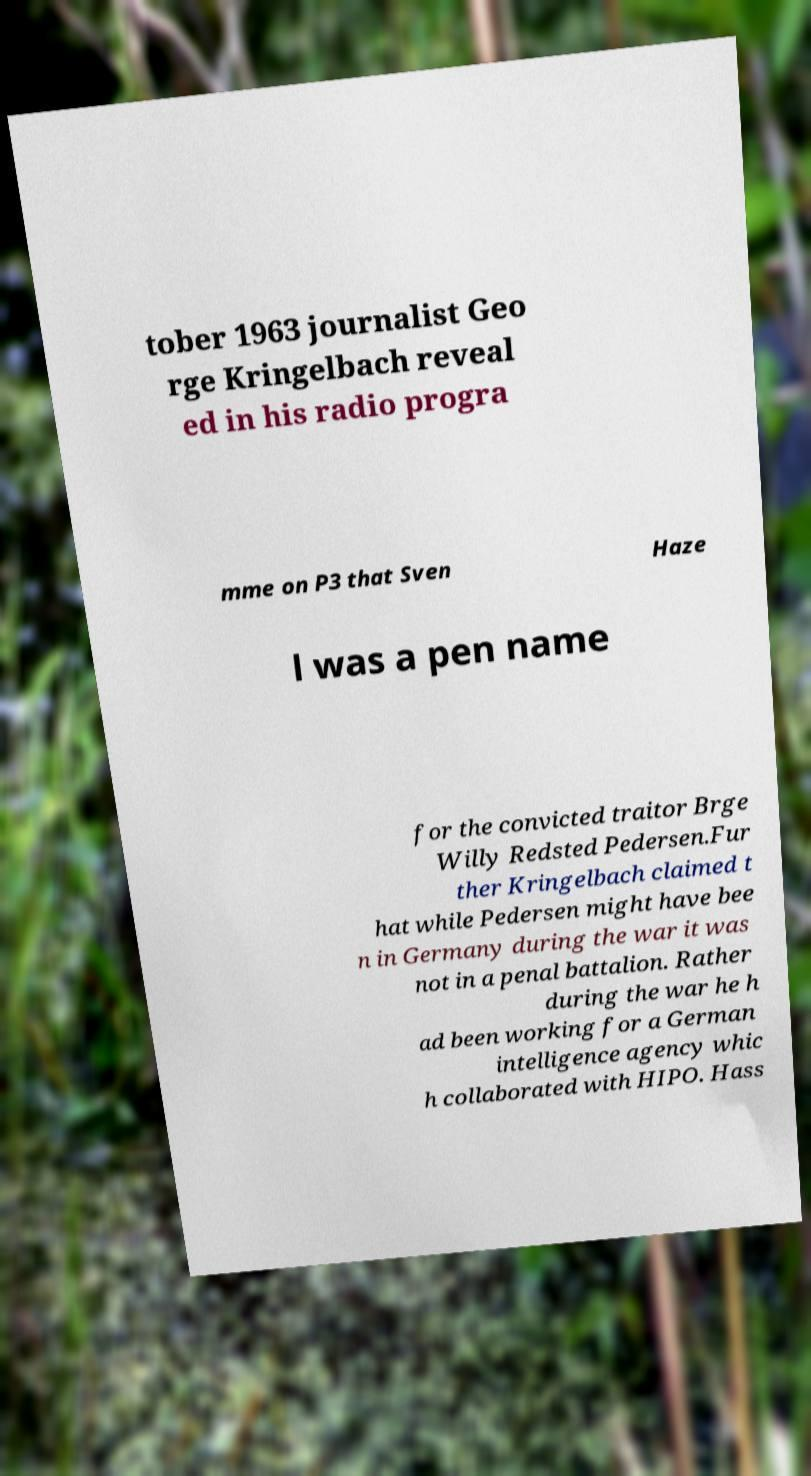Could you assist in decoding the text presented in this image and type it out clearly? tober 1963 journalist Geo rge Kringelbach reveal ed in his radio progra mme on P3 that Sven Haze l was a pen name for the convicted traitor Brge Willy Redsted Pedersen.Fur ther Kringelbach claimed t hat while Pedersen might have bee n in Germany during the war it was not in a penal battalion. Rather during the war he h ad been working for a German intelligence agency whic h collaborated with HIPO. Hass 